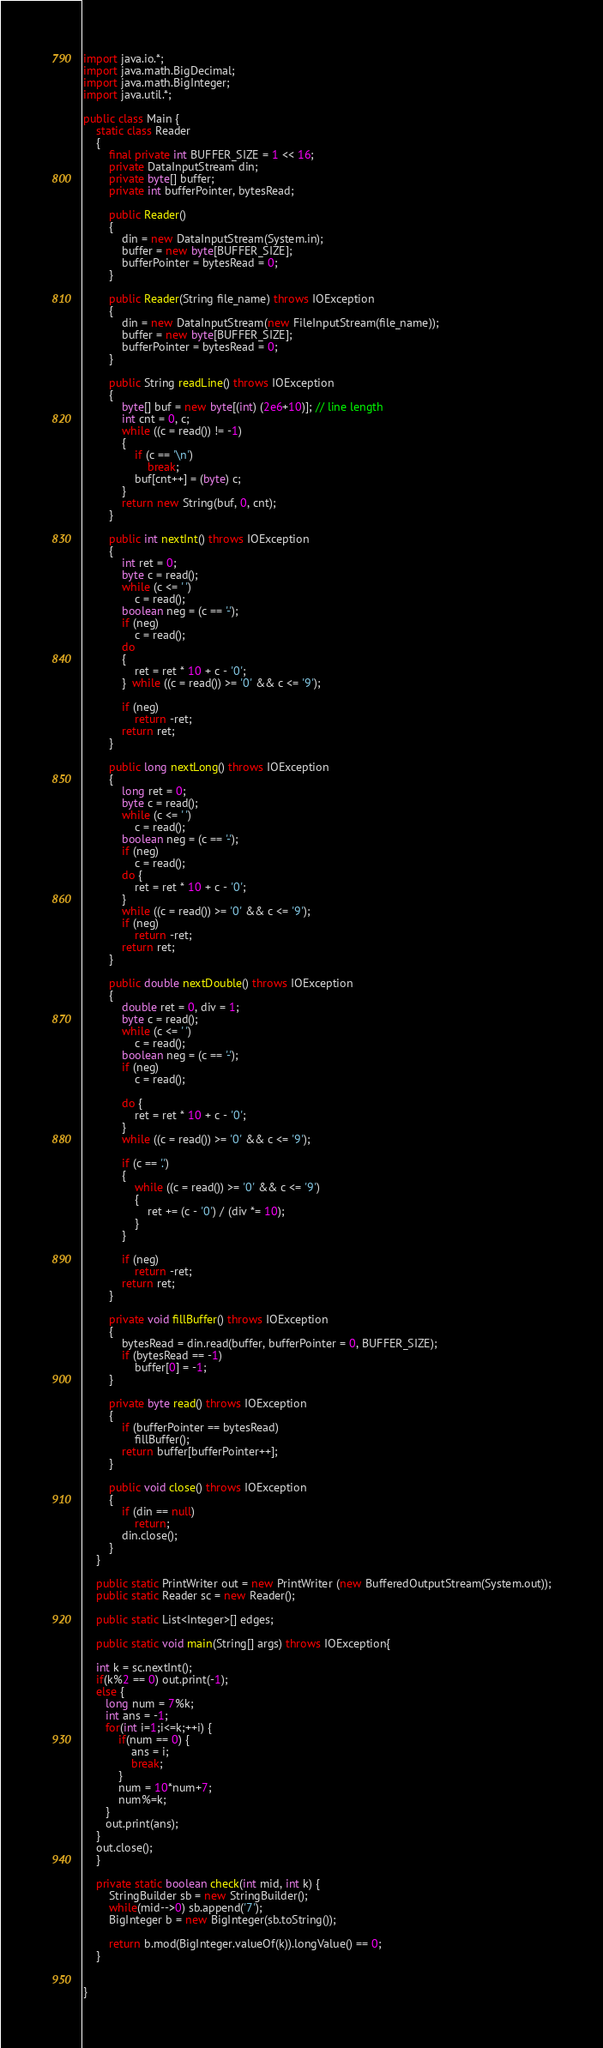Convert code to text. <code><loc_0><loc_0><loc_500><loc_500><_Java_>import java.io.*;
import java.math.BigDecimal;
import java.math.BigInteger;
import java.util.*;

public class Main {
	static class Reader 
    { 
        final private int BUFFER_SIZE = 1 << 16; 
        private DataInputStream din; 
        private byte[] buffer; 
        private int bufferPointer, bytesRead; 
  
        public Reader() 
        { 
            din = new DataInputStream(System.in); 
            buffer = new byte[BUFFER_SIZE]; 
            bufferPointer = bytesRead = 0; 
        } 
  
        public Reader(String file_name) throws IOException 
        { 
            din = new DataInputStream(new FileInputStream(file_name)); 
            buffer = new byte[BUFFER_SIZE]; 
            bufferPointer = bytesRead = 0; 
        } 
  
        public String readLine() throws IOException 
        { 
            byte[] buf = new byte[(int) (2e6+10)]; // line length 
            int cnt = 0, c; 
            while ((c = read()) != -1) 
            { 
                if (c == '\n') 
                    break; 
                buf[cnt++] = (byte) c; 
            } 
            return new String(buf, 0, cnt); 
        } 
  
        public int nextInt() throws IOException 
        { 
            int ret = 0; 
            byte c = read(); 
            while (c <= ' ') 
                c = read(); 
            boolean neg = (c == '-'); 
            if (neg) 
                c = read(); 
            do
            { 
                ret = ret * 10 + c - '0'; 
            }  while ((c = read()) >= '0' && c <= '9'); 
  
            if (neg) 
                return -ret; 
            return ret; 
        } 
  
        public long nextLong() throws IOException 
        { 
            long ret = 0; 
            byte c = read(); 
            while (c <= ' ') 
                c = read(); 
            boolean neg = (c == '-'); 
            if (neg) 
                c = read(); 
            do { 
                ret = ret * 10 + c - '0'; 
            } 
            while ((c = read()) >= '0' && c <= '9'); 
            if (neg) 
                return -ret; 
            return ret; 
        } 
  
        public double nextDouble() throws IOException 
        { 
            double ret = 0, div = 1; 
            byte c = read(); 
            while (c <= ' ') 
                c = read(); 
            boolean neg = (c == '-'); 
            if (neg) 
                c = read(); 
  
            do { 
                ret = ret * 10 + c - '0'; 
            } 
            while ((c = read()) >= '0' && c <= '9'); 
  
            if (c == '.') 
            { 
                while ((c = read()) >= '0' && c <= '9') 
                { 
                    ret += (c - '0') / (div *= 10); 
                } 
            } 
  
            if (neg) 
                return -ret; 
            return ret; 
        } 
  
        private void fillBuffer() throws IOException 
        { 
            bytesRead = din.read(buffer, bufferPointer = 0, BUFFER_SIZE); 
            if (bytesRead == -1) 
                buffer[0] = -1; 
        } 
  
        private byte read() throws IOException 
        { 
            if (bufferPointer == bytesRead) 
                fillBuffer(); 
            return buffer[bufferPointer++]; 
        } 
  
        public void close() throws IOException 
        { 
            if (din == null) 
                return; 
            din.close(); 
        } 
    }

	public static PrintWriter out = new PrintWriter (new BufferedOutputStream(System.out));
	public static Reader sc = new Reader();

	public static List<Integer>[] edges;
	
	public static void main(String[] args) throws IOException{
	
	int k = sc.nextInt();
	if(k%2 == 0) out.print(-1);
	else {
	   long num = 7%k;
	   int ans = -1;
	   for(int i=1;i<=k;++i) {
		   if(num == 0) {
			   ans = i;
			   break;
		   }
		   num = 10*num+7;
		   num%=k;
	   }
	   out.print(ans);
	}
	out.close();
	}

	private static boolean check(int mid, int k) {
		StringBuilder sb = new StringBuilder();
		while(mid-->0) sb.append('7');
		BigInteger b = new BigInteger(sb.toString());
		
		return b.mod(BigInteger.valueOf(k)).longValue() == 0;
	}

	
}</code> 